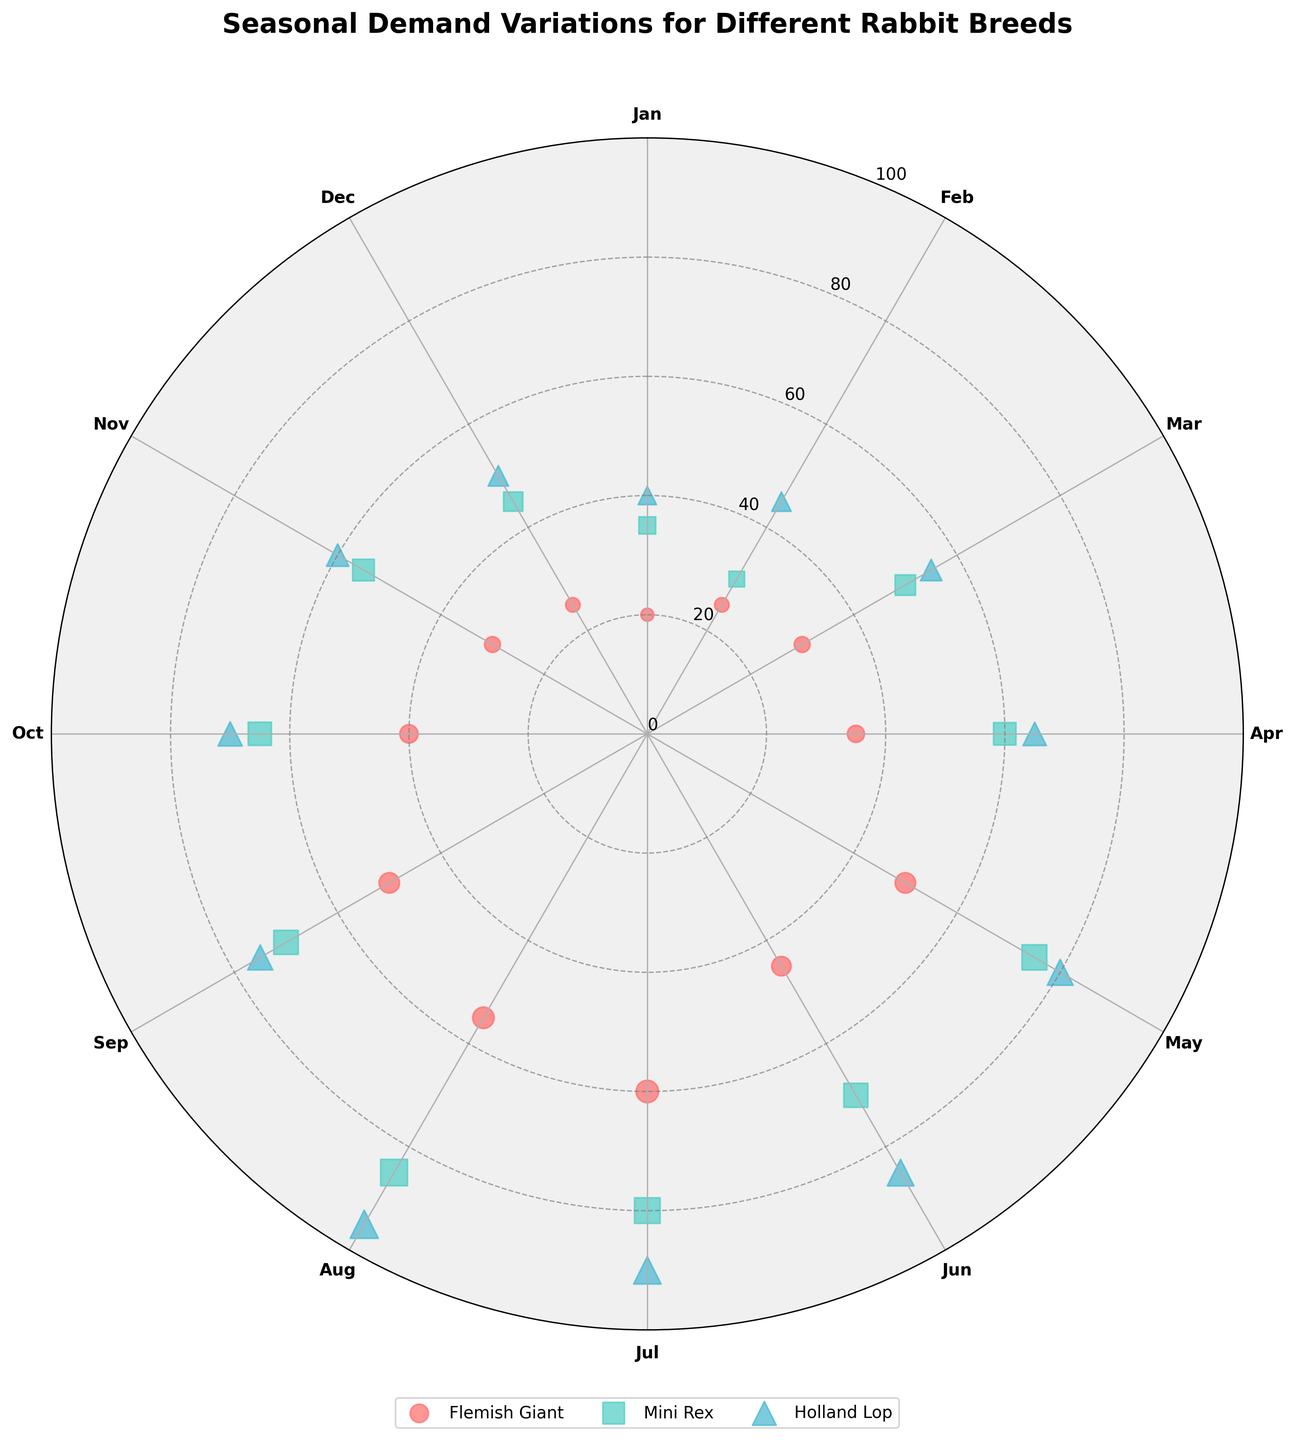What is the title of the figure? The title of the figure is located at the top of the chart. It introduces the main topic or purpose of the chart. It says, "Seasonal Demand Variations for Different Rabbit Breeds".
Answer: Seasonal Demand Variations for Different Rabbit Breeds What breeds are represented in the chart? By looking at the legend at the bottom of the figure, we can see the breeds represented. The legend shows the different symbols and corresponding breeds. There are three breeds: Flemish Giant, Mini Rex, and Holland Lop.
Answer: Flemish Giant, Mini Rex, Holland Lop Which breed has the highest demand in July? To find the highest demand in July, locate July on the polar chart (210 degrees). The data points for each breed for July can be seen there. It shows that Holland Lop has the highest demand.
Answer: Holland Lop How does the demand for Mini Rex change from March to April? To see the change in demand for Mini Rex, look at the data points for Mini Rex in March (90 degrees) and April (120 degrees). The demand in March is around 50, while in April it is 60. Therefore, the demand increases by 10.
Answer: Increases by 10 Which month has the lowest overall demand for rabbits? To find the month with the lowest overall demand, examine each month and sum the demands for all breeds. January shows the lowest overall demand (20 for Flemish Giant, 35 for Mini Rex, and 40 for Holland Lop), summing up to 95.
Answer: January What's the difference in demand for Flemish Giant between May and August? Locate the data points for Flemish Giant in May (150 degrees) and August (240 degrees). The demand in May is 50, while in August it's 55. Subtracting these gives a difference of 5.
Answer: 5 Which breed has the most significant increase in demand from June to July? To determine the most significant increase, compare the demand changes for all breeds between June (180 degrees) and July (210 degrees). Flemish Giant increases from 45 to 60 (15 units), Mini Rex from 70 to 80 (10 units), and Holland Lop from 85 to 90 (5 units). The Flemish Giant has the highest increase.
Answer: Flemish Giant What is the average demand for Holland Lop from October to December? Look at the data points for Holland Lop in October (300 degrees), November (330 degrees), and December (0 or 360 degrees). The demands are 70, 60, and 50, respectively. The average is calculated as (70 + 60 + 50)/3 = 60.
Answer: 60 Which month experiences the highest peak in demand for any rabbit breed? To identify the highest peak demand, scan through each month's data points. August shows the highest with Holland Lop reaching a demand of 95.
Answer: August How does the demand trend for Flemish Giant change throughout the year? To understand the trend, observe the data points for Flemish Giant at each 30-degree interval representing months from January to December. The demand shows a generally increasing trend up to July, peaking at 60, and then decreasing towards the end of the year, ending at 25.
Answer: Increases to July, then decreases 